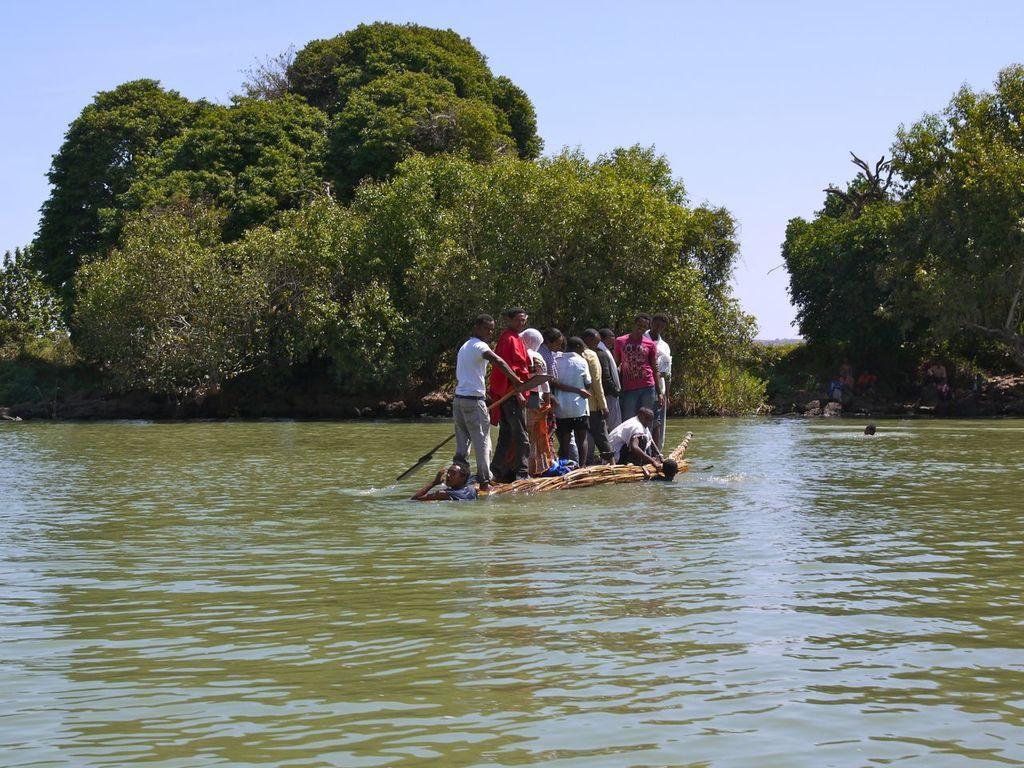Describe this image in one or two sentences. This picture is of outside the city. In the foreground we can see a water body in which we can see a boat and group of people standing on the boat and a person squatting on the boat. In the background we can see the sky, trees and plants. 